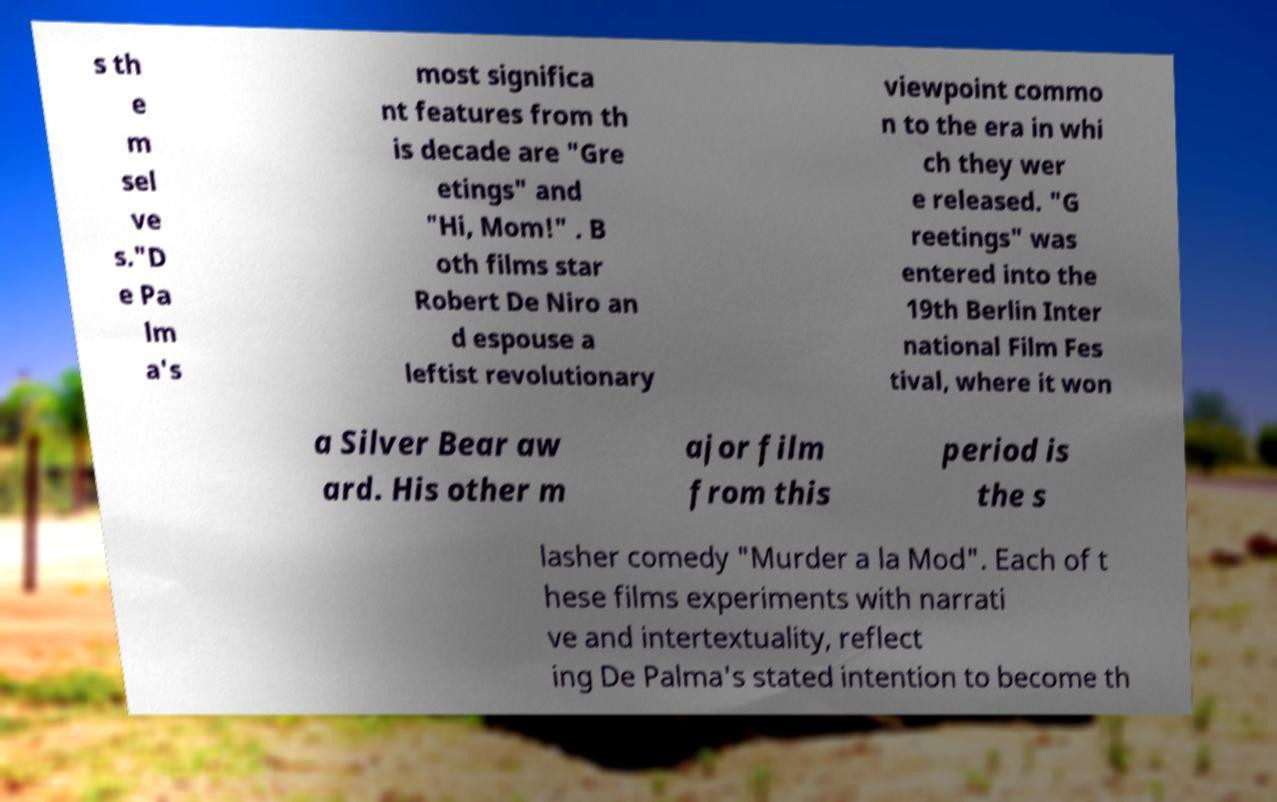Could you assist in decoding the text presented in this image and type it out clearly? s th e m sel ve s."D e Pa lm a's most significa nt features from th is decade are "Gre etings" and "Hi, Mom!" . B oth films star Robert De Niro an d espouse a leftist revolutionary viewpoint commo n to the era in whi ch they wer e released. "G reetings" was entered into the 19th Berlin Inter national Film Fes tival, where it won a Silver Bear aw ard. His other m ajor film from this period is the s lasher comedy "Murder a la Mod". Each of t hese films experiments with narrati ve and intertextuality, reflect ing De Palma's stated intention to become th 